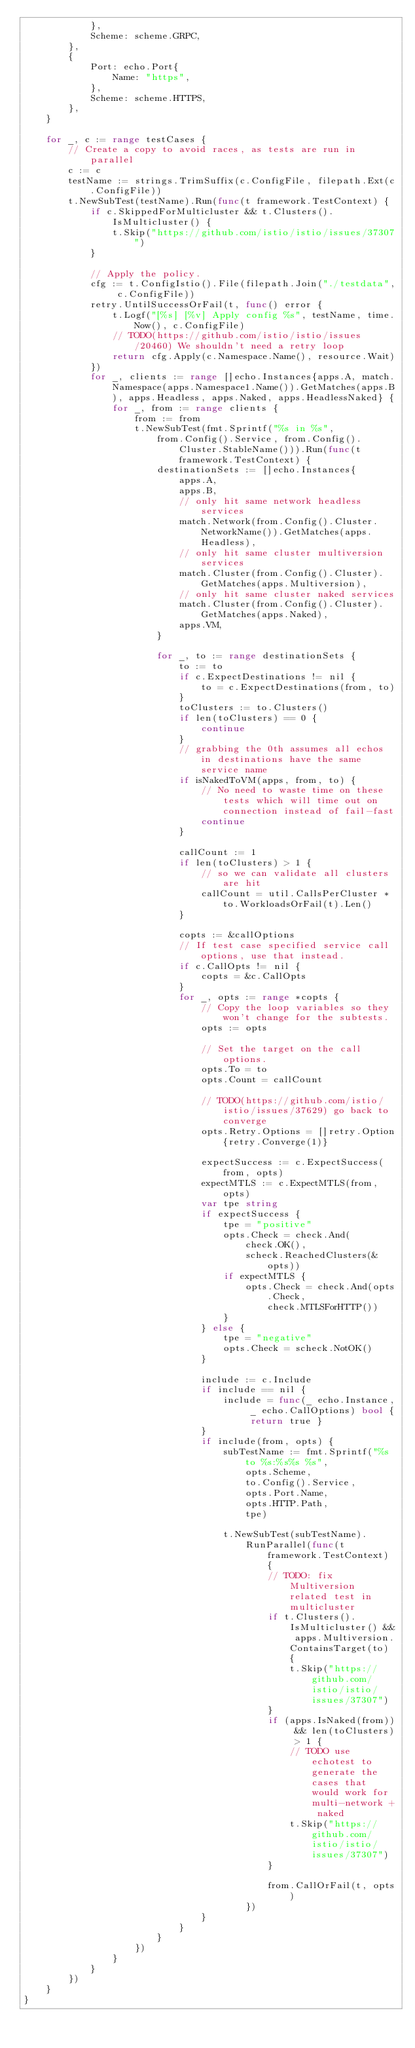<code> <loc_0><loc_0><loc_500><loc_500><_Go_>			},
			Scheme: scheme.GRPC,
		},
		{
			Port: echo.Port{
				Name: "https",
			},
			Scheme: scheme.HTTPS,
		},
	}

	for _, c := range testCases {
		// Create a copy to avoid races, as tests are run in parallel
		c := c
		testName := strings.TrimSuffix(c.ConfigFile, filepath.Ext(c.ConfigFile))
		t.NewSubTest(testName).Run(func(t framework.TestContext) {
			if c.SkippedForMulticluster && t.Clusters().IsMulticluster() {
				t.Skip("https://github.com/istio/istio/issues/37307")
			}

			// Apply the policy.
			cfg := t.ConfigIstio().File(filepath.Join("./testdata", c.ConfigFile))
			retry.UntilSuccessOrFail(t, func() error {
				t.Logf("[%s] [%v] Apply config %s", testName, time.Now(), c.ConfigFile)
				// TODO(https://github.com/istio/istio/issues/20460) We shouldn't need a retry loop
				return cfg.Apply(c.Namespace.Name(), resource.Wait)
			})
			for _, clients := range []echo.Instances{apps.A, match.Namespace(apps.Namespace1.Name()).GetMatches(apps.B), apps.Headless, apps.Naked, apps.HeadlessNaked} {
				for _, from := range clients {
					from := from
					t.NewSubTest(fmt.Sprintf("%s in %s",
						from.Config().Service, from.Config().Cluster.StableName())).Run(func(t framework.TestContext) {
						destinationSets := []echo.Instances{
							apps.A,
							apps.B,
							// only hit same network headless services
							match.Network(from.Config().Cluster.NetworkName()).GetMatches(apps.Headless),
							// only hit same cluster multiversion services
							match.Cluster(from.Config().Cluster).GetMatches(apps.Multiversion),
							// only hit same cluster naked services
							match.Cluster(from.Config().Cluster).GetMatches(apps.Naked),
							apps.VM,
						}

						for _, to := range destinationSets {
							to := to
							if c.ExpectDestinations != nil {
								to = c.ExpectDestinations(from, to)
							}
							toClusters := to.Clusters()
							if len(toClusters) == 0 {
								continue
							}
							// grabbing the 0th assumes all echos in destinations have the same service name
							if isNakedToVM(apps, from, to) {
								// No need to waste time on these tests which will time out on connection instead of fail-fast
								continue
							}

							callCount := 1
							if len(toClusters) > 1 {
								// so we can validate all clusters are hit
								callCount = util.CallsPerCluster * to.WorkloadsOrFail(t).Len()
							}

							copts := &callOptions
							// If test case specified service call options, use that instead.
							if c.CallOpts != nil {
								copts = &c.CallOpts
							}
							for _, opts := range *copts {
								// Copy the loop variables so they won't change for the subtests.
								opts := opts

								// Set the target on the call options.
								opts.To = to
								opts.Count = callCount

								// TODO(https://github.com/istio/istio/issues/37629) go back to converge
								opts.Retry.Options = []retry.Option{retry.Converge(1)}

								expectSuccess := c.ExpectSuccess(from, opts)
								expectMTLS := c.ExpectMTLS(from, opts)
								var tpe string
								if expectSuccess {
									tpe = "positive"
									opts.Check = check.And(
										check.OK(),
										scheck.ReachedClusters(&opts))
									if expectMTLS {
										opts.Check = check.And(opts.Check,
											check.MTLSForHTTP())
									}
								} else {
									tpe = "negative"
									opts.Check = scheck.NotOK()
								}

								include := c.Include
								if include == nil {
									include = func(_ echo.Instance, _ echo.CallOptions) bool { return true }
								}
								if include(from, opts) {
									subTestName := fmt.Sprintf("%s to %s:%s%s %s",
										opts.Scheme,
										to.Config().Service,
										opts.Port.Name,
										opts.HTTP.Path,
										tpe)

									t.NewSubTest(subTestName).
										RunParallel(func(t framework.TestContext) {
											// TODO: fix Multiversion related test in multicluster
											if t.Clusters().IsMulticluster() && apps.Multiversion.ContainsTarget(to) {
												t.Skip("https://github.com/istio/istio/issues/37307")
											}
											if (apps.IsNaked(from)) && len(toClusters) > 1 {
												// TODO use echotest to generate the cases that would work for multi-network + naked
												t.Skip("https://github.com/istio/istio/issues/37307")
											}

											from.CallOrFail(t, opts)
										})
								}
							}
						}
					})
				}
			}
		})
	}
}
</code> 